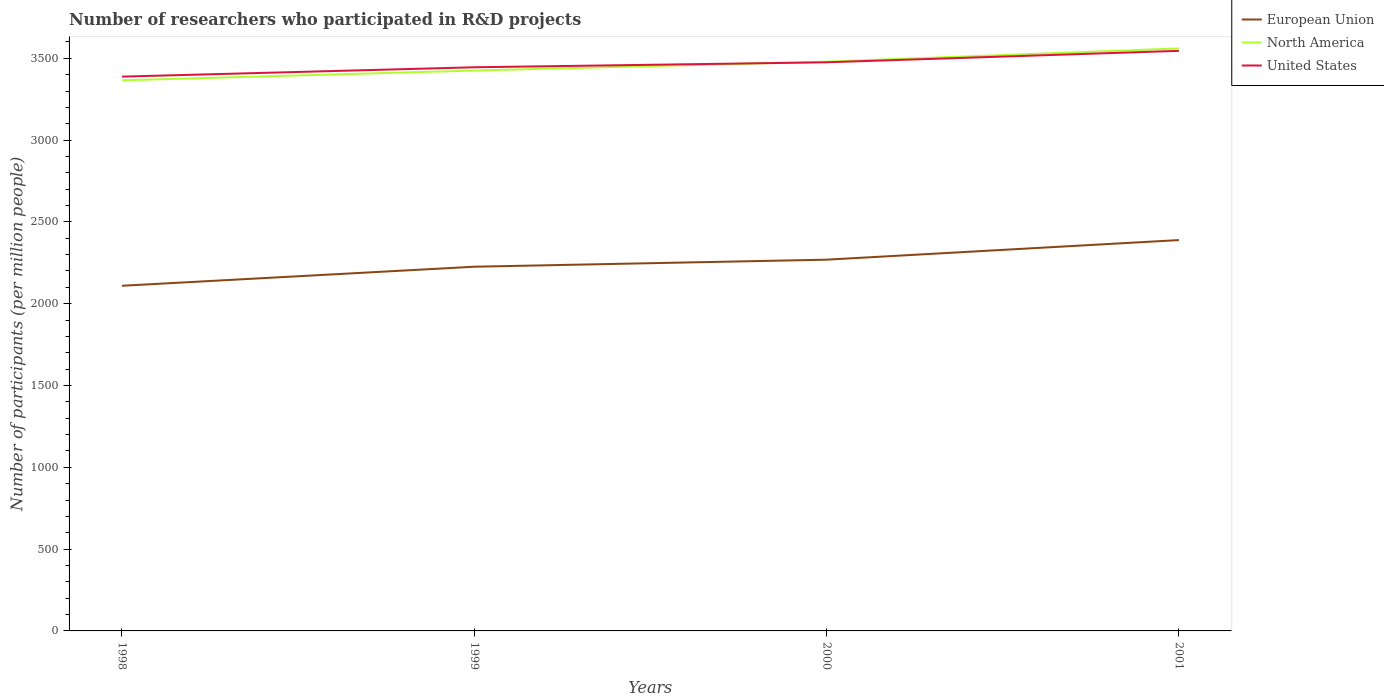Does the line corresponding to United States intersect with the line corresponding to North America?
Offer a very short reply. Yes. Is the number of lines equal to the number of legend labels?
Give a very brief answer. Yes. Across all years, what is the maximum number of researchers who participated in R&D projects in North America?
Provide a short and direct response. 3365.33. In which year was the number of researchers who participated in R&D projects in North America maximum?
Ensure brevity in your answer.  1998. What is the total number of researchers who participated in R&D projects in European Union in the graph?
Offer a terse response. -119.76. What is the difference between the highest and the second highest number of researchers who participated in R&D projects in European Union?
Keep it short and to the point. 279.24. What is the difference between the highest and the lowest number of researchers who participated in R&D projects in North America?
Provide a succinct answer. 2. How many lines are there?
Offer a very short reply. 3. How many years are there in the graph?
Your answer should be very brief. 4. Are the values on the major ticks of Y-axis written in scientific E-notation?
Provide a succinct answer. No. Does the graph contain grids?
Your answer should be compact. No. What is the title of the graph?
Offer a terse response. Number of researchers who participated in R&D projects. Does "Brazil" appear as one of the legend labels in the graph?
Your response must be concise. No. What is the label or title of the X-axis?
Provide a short and direct response. Years. What is the label or title of the Y-axis?
Your answer should be compact. Number of participants (per million people). What is the Number of participants (per million people) in European Union in 1998?
Provide a succinct answer. 2109.67. What is the Number of participants (per million people) of North America in 1998?
Your response must be concise. 3365.33. What is the Number of participants (per million people) of United States in 1998?
Your response must be concise. 3388.01. What is the Number of participants (per million people) in European Union in 1999?
Your answer should be very brief. 2226.11. What is the Number of participants (per million people) of North America in 1999?
Keep it short and to the point. 3425.18. What is the Number of participants (per million people) of United States in 1999?
Give a very brief answer. 3445.1. What is the Number of participants (per million people) in European Union in 2000?
Give a very brief answer. 2269.16. What is the Number of participants (per million people) of North America in 2000?
Your response must be concise. 3479.34. What is the Number of participants (per million people) in United States in 2000?
Give a very brief answer. 3475.52. What is the Number of participants (per million people) of European Union in 2001?
Make the answer very short. 2388.92. What is the Number of participants (per million people) in North America in 2001?
Ensure brevity in your answer.  3560.24. What is the Number of participants (per million people) in United States in 2001?
Provide a succinct answer. 3545.56. Across all years, what is the maximum Number of participants (per million people) in European Union?
Ensure brevity in your answer.  2388.92. Across all years, what is the maximum Number of participants (per million people) of North America?
Your answer should be very brief. 3560.24. Across all years, what is the maximum Number of participants (per million people) of United States?
Ensure brevity in your answer.  3545.56. Across all years, what is the minimum Number of participants (per million people) of European Union?
Your response must be concise. 2109.67. Across all years, what is the minimum Number of participants (per million people) of North America?
Your answer should be compact. 3365.33. Across all years, what is the minimum Number of participants (per million people) in United States?
Give a very brief answer. 3388.01. What is the total Number of participants (per million people) in European Union in the graph?
Provide a short and direct response. 8993.86. What is the total Number of participants (per million people) of North America in the graph?
Keep it short and to the point. 1.38e+04. What is the total Number of participants (per million people) in United States in the graph?
Ensure brevity in your answer.  1.39e+04. What is the difference between the Number of participants (per million people) in European Union in 1998 and that in 1999?
Offer a very short reply. -116.43. What is the difference between the Number of participants (per million people) of North America in 1998 and that in 1999?
Your response must be concise. -59.84. What is the difference between the Number of participants (per million people) of United States in 1998 and that in 1999?
Offer a terse response. -57.1. What is the difference between the Number of participants (per million people) in European Union in 1998 and that in 2000?
Your answer should be compact. -159.48. What is the difference between the Number of participants (per million people) of North America in 1998 and that in 2000?
Keep it short and to the point. -114.01. What is the difference between the Number of participants (per million people) in United States in 1998 and that in 2000?
Your response must be concise. -87.51. What is the difference between the Number of participants (per million people) in European Union in 1998 and that in 2001?
Give a very brief answer. -279.24. What is the difference between the Number of participants (per million people) in North America in 1998 and that in 2001?
Offer a very short reply. -194.91. What is the difference between the Number of participants (per million people) in United States in 1998 and that in 2001?
Provide a short and direct response. -157.55. What is the difference between the Number of participants (per million people) in European Union in 1999 and that in 2000?
Provide a short and direct response. -43.05. What is the difference between the Number of participants (per million people) of North America in 1999 and that in 2000?
Provide a short and direct response. -54.17. What is the difference between the Number of participants (per million people) of United States in 1999 and that in 2000?
Your answer should be compact. -30.41. What is the difference between the Number of participants (per million people) in European Union in 1999 and that in 2001?
Your answer should be very brief. -162.81. What is the difference between the Number of participants (per million people) in North America in 1999 and that in 2001?
Provide a short and direct response. -135.07. What is the difference between the Number of participants (per million people) in United States in 1999 and that in 2001?
Give a very brief answer. -100.45. What is the difference between the Number of participants (per million people) in European Union in 2000 and that in 2001?
Offer a terse response. -119.76. What is the difference between the Number of participants (per million people) of North America in 2000 and that in 2001?
Your answer should be very brief. -80.9. What is the difference between the Number of participants (per million people) in United States in 2000 and that in 2001?
Offer a terse response. -70.04. What is the difference between the Number of participants (per million people) of European Union in 1998 and the Number of participants (per million people) of North America in 1999?
Your response must be concise. -1315.5. What is the difference between the Number of participants (per million people) of European Union in 1998 and the Number of participants (per million people) of United States in 1999?
Your answer should be very brief. -1335.43. What is the difference between the Number of participants (per million people) of North America in 1998 and the Number of participants (per million people) of United States in 1999?
Keep it short and to the point. -79.77. What is the difference between the Number of participants (per million people) in European Union in 1998 and the Number of participants (per million people) in North America in 2000?
Make the answer very short. -1369.67. What is the difference between the Number of participants (per million people) of European Union in 1998 and the Number of participants (per million people) of United States in 2000?
Offer a terse response. -1365.84. What is the difference between the Number of participants (per million people) of North America in 1998 and the Number of participants (per million people) of United States in 2000?
Provide a succinct answer. -110.18. What is the difference between the Number of participants (per million people) in European Union in 1998 and the Number of participants (per million people) in North America in 2001?
Offer a very short reply. -1450.57. What is the difference between the Number of participants (per million people) of European Union in 1998 and the Number of participants (per million people) of United States in 2001?
Provide a short and direct response. -1435.88. What is the difference between the Number of participants (per million people) in North America in 1998 and the Number of participants (per million people) in United States in 2001?
Offer a very short reply. -180.23. What is the difference between the Number of participants (per million people) of European Union in 1999 and the Number of participants (per million people) of North America in 2000?
Your answer should be very brief. -1253.24. What is the difference between the Number of participants (per million people) in European Union in 1999 and the Number of participants (per million people) in United States in 2000?
Keep it short and to the point. -1249.41. What is the difference between the Number of participants (per million people) of North America in 1999 and the Number of participants (per million people) of United States in 2000?
Provide a short and direct response. -50.34. What is the difference between the Number of participants (per million people) of European Union in 1999 and the Number of participants (per million people) of North America in 2001?
Your response must be concise. -1334.14. What is the difference between the Number of participants (per million people) in European Union in 1999 and the Number of participants (per million people) in United States in 2001?
Make the answer very short. -1319.45. What is the difference between the Number of participants (per million people) in North America in 1999 and the Number of participants (per million people) in United States in 2001?
Provide a short and direct response. -120.38. What is the difference between the Number of participants (per million people) of European Union in 2000 and the Number of participants (per million people) of North America in 2001?
Offer a very short reply. -1291.09. What is the difference between the Number of participants (per million people) of European Union in 2000 and the Number of participants (per million people) of United States in 2001?
Your answer should be compact. -1276.4. What is the difference between the Number of participants (per million people) of North America in 2000 and the Number of participants (per million people) of United States in 2001?
Keep it short and to the point. -66.21. What is the average Number of participants (per million people) in European Union per year?
Provide a short and direct response. 2248.46. What is the average Number of participants (per million people) in North America per year?
Your answer should be very brief. 3457.52. What is the average Number of participants (per million people) of United States per year?
Your response must be concise. 3463.55. In the year 1998, what is the difference between the Number of participants (per million people) of European Union and Number of participants (per million people) of North America?
Ensure brevity in your answer.  -1255.66. In the year 1998, what is the difference between the Number of participants (per million people) of European Union and Number of participants (per million people) of United States?
Provide a succinct answer. -1278.33. In the year 1998, what is the difference between the Number of participants (per million people) of North America and Number of participants (per million people) of United States?
Offer a terse response. -22.68. In the year 1999, what is the difference between the Number of participants (per million people) in European Union and Number of participants (per million people) in North America?
Your response must be concise. -1199.07. In the year 1999, what is the difference between the Number of participants (per million people) of European Union and Number of participants (per million people) of United States?
Give a very brief answer. -1219. In the year 1999, what is the difference between the Number of participants (per million people) in North America and Number of participants (per million people) in United States?
Offer a very short reply. -19.93. In the year 2000, what is the difference between the Number of participants (per million people) of European Union and Number of participants (per million people) of North America?
Your response must be concise. -1210.18. In the year 2000, what is the difference between the Number of participants (per million people) of European Union and Number of participants (per million people) of United States?
Give a very brief answer. -1206.36. In the year 2000, what is the difference between the Number of participants (per million people) in North America and Number of participants (per million people) in United States?
Your answer should be very brief. 3.83. In the year 2001, what is the difference between the Number of participants (per million people) in European Union and Number of participants (per million people) in North America?
Your answer should be compact. -1171.33. In the year 2001, what is the difference between the Number of participants (per million people) of European Union and Number of participants (per million people) of United States?
Make the answer very short. -1156.64. In the year 2001, what is the difference between the Number of participants (per million people) in North America and Number of participants (per million people) in United States?
Ensure brevity in your answer.  14.69. What is the ratio of the Number of participants (per million people) of European Union in 1998 to that in 1999?
Offer a terse response. 0.95. What is the ratio of the Number of participants (per million people) in North America in 1998 to that in 1999?
Your response must be concise. 0.98. What is the ratio of the Number of participants (per million people) in United States in 1998 to that in 1999?
Ensure brevity in your answer.  0.98. What is the ratio of the Number of participants (per million people) of European Union in 1998 to that in 2000?
Keep it short and to the point. 0.93. What is the ratio of the Number of participants (per million people) in North America in 1998 to that in 2000?
Provide a short and direct response. 0.97. What is the ratio of the Number of participants (per million people) of United States in 1998 to that in 2000?
Offer a very short reply. 0.97. What is the ratio of the Number of participants (per million people) of European Union in 1998 to that in 2001?
Offer a very short reply. 0.88. What is the ratio of the Number of participants (per million people) of North America in 1998 to that in 2001?
Provide a short and direct response. 0.95. What is the ratio of the Number of participants (per million people) of United States in 1998 to that in 2001?
Make the answer very short. 0.96. What is the ratio of the Number of participants (per million people) of European Union in 1999 to that in 2000?
Provide a succinct answer. 0.98. What is the ratio of the Number of participants (per million people) of North America in 1999 to that in 2000?
Your answer should be compact. 0.98. What is the ratio of the Number of participants (per million people) in United States in 1999 to that in 2000?
Offer a terse response. 0.99. What is the ratio of the Number of participants (per million people) of European Union in 1999 to that in 2001?
Your answer should be very brief. 0.93. What is the ratio of the Number of participants (per million people) in North America in 1999 to that in 2001?
Offer a terse response. 0.96. What is the ratio of the Number of participants (per million people) in United States in 1999 to that in 2001?
Provide a succinct answer. 0.97. What is the ratio of the Number of participants (per million people) in European Union in 2000 to that in 2001?
Provide a succinct answer. 0.95. What is the ratio of the Number of participants (per million people) of North America in 2000 to that in 2001?
Make the answer very short. 0.98. What is the ratio of the Number of participants (per million people) of United States in 2000 to that in 2001?
Provide a succinct answer. 0.98. What is the difference between the highest and the second highest Number of participants (per million people) in European Union?
Offer a very short reply. 119.76. What is the difference between the highest and the second highest Number of participants (per million people) of North America?
Your answer should be very brief. 80.9. What is the difference between the highest and the second highest Number of participants (per million people) of United States?
Your response must be concise. 70.04. What is the difference between the highest and the lowest Number of participants (per million people) of European Union?
Keep it short and to the point. 279.24. What is the difference between the highest and the lowest Number of participants (per million people) in North America?
Your answer should be compact. 194.91. What is the difference between the highest and the lowest Number of participants (per million people) of United States?
Ensure brevity in your answer.  157.55. 